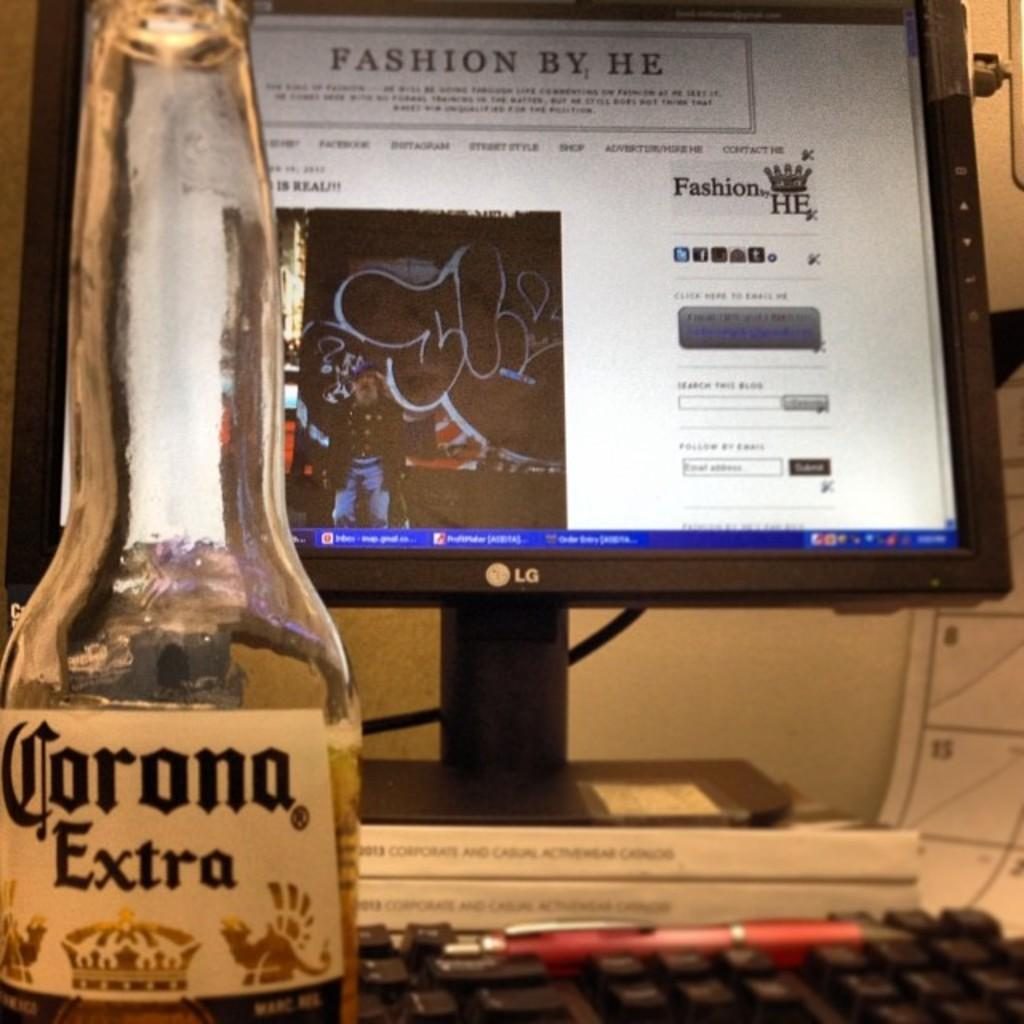<image>
Summarize the visual content of the image. An LG monitor displaying Fashion by He with a bottle of Corona Extra and red ball point pen near it 